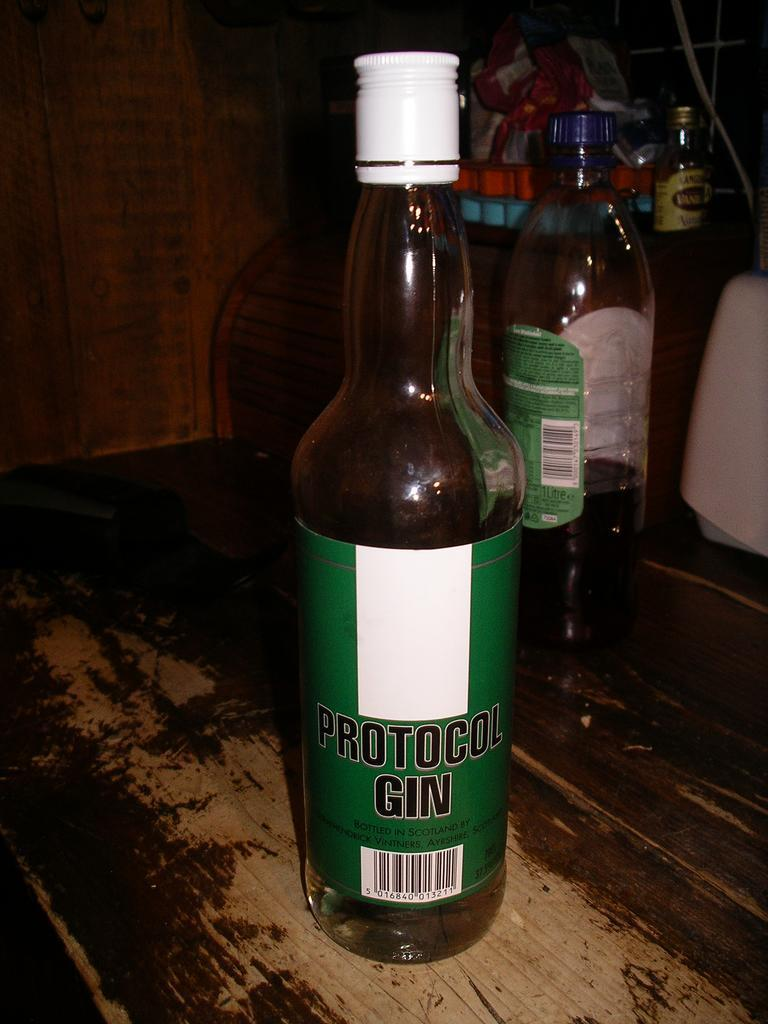Provide a one-sentence caption for the provided image. A bottle of Protocol Gin standing in front of two other bottles. 